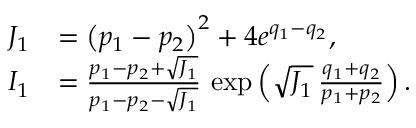Convert formula to latex. <formula><loc_0><loc_0><loc_500><loc_500>\begin{array} { r l } { J _ { 1 } } & { = \left ( p _ { 1 } - p _ { 2 } \right ) ^ { 2 } + 4 e ^ { q _ { 1 } - q _ { 2 } } , } \\ { I _ { 1 } } & { = \frac { p _ { 1 } - p _ { 2 } + \sqrt { J _ { 1 } } } { p _ { 1 } - p _ { 2 } - \sqrt { J _ { 1 } } } \, \exp \left ( { \sqrt { J _ { 1 } } \, \frac { q _ { 1 } + q _ { 2 } } { p _ { 1 } + p _ { 2 } } } \right ) . } \end{array}</formula> 